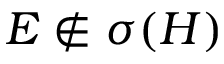<formula> <loc_0><loc_0><loc_500><loc_500>E \notin \sigma ( H )</formula> 